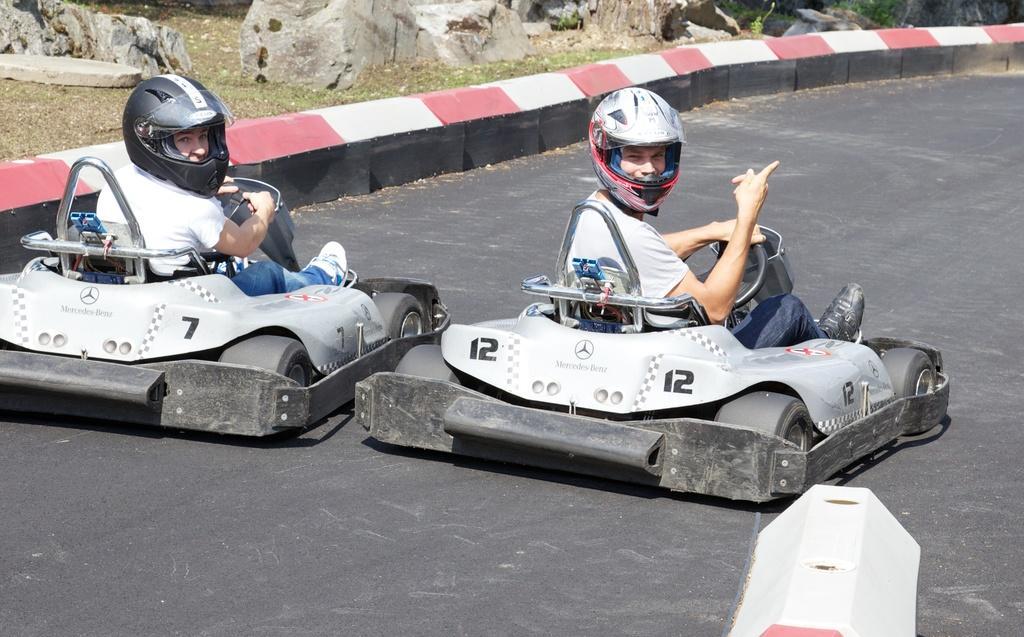In one or two sentences, can you explain what this image depicts? Here there are two persons riding two vehicles on the road. In the background we can see stones and grass. On the right at the bottom we can see a divider. 